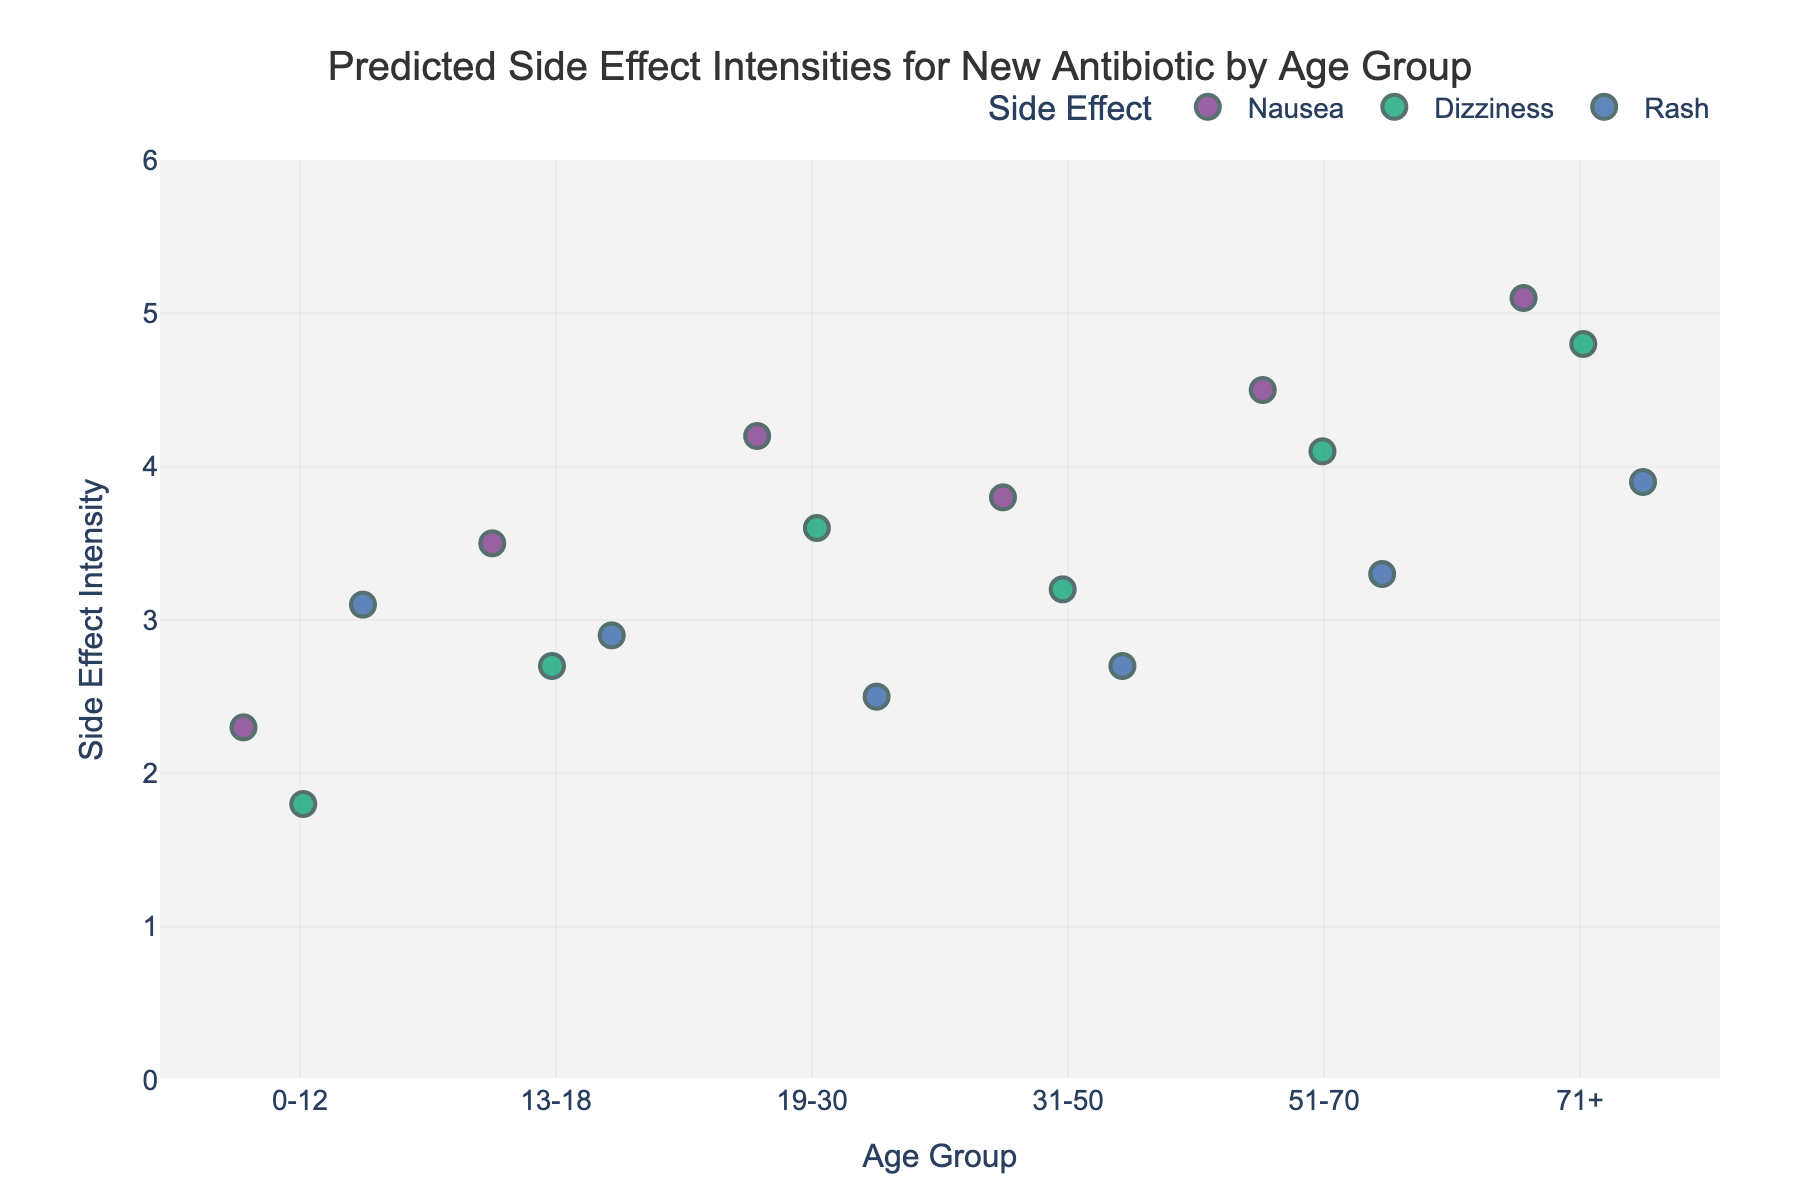Which age group has the highest intensity of nausea? First, find the points for nausea. The 71+ age group has the highest nausea intensity at 5.1.
Answer: 71+ What is the average intensity of dizziness across all age groups? Sum the dizziness intensities: 1.8 + 2.7 + 3.6 + 3.2 + 4.1 + 4.8 = 20.2, and divide by 6 (number of age groups): 20.2/6 ≈ 3.37
Answer: 3.37 Between the 13-18 and 31-50 age groups, which one has higher side effect intensities for rash? Compare the values: 13-18 has a rash intensity of 2.9, while 31-50 has 2.7. Therefore, 13-18 has higher rash intensity.
Answer: 13-18 How does the intensity of dizziness change from the 0-12 to the 51-70 age group? The dizziness intensity increases: 1.8 (0-12) to 4.1 (51-70), rising consistently across the age groups in between.
Answer: It increases What is the overall trend in nausea intensity as age increases? Overall, nausea intensity increases with age, from 2.3 (0-12) to 5.1 (71+).
Answer: Increases Which side effect shows the least variation in intensity across different age groups? By visually inspecting the spread of values for each side effect, rash appears to have the least variation.
Answer: Rash Can you identify any outliers in the side effect intensities? No obvious outliers can be spotted as all data points for side effect intensities are within a fairly tight range on the strip plot.
Answer: None identified Which age group has the largest range of side effect intensities? The 71+ age group shows intensities from 3.9 to 5.1, thus having the largest range.
Answer: 71+ What is the median intensity of side effects for the 19-30 age group? Order their intensities: 2.5, 3.6, 4.2. The middle value is 3.6.
Answer: 3.6 